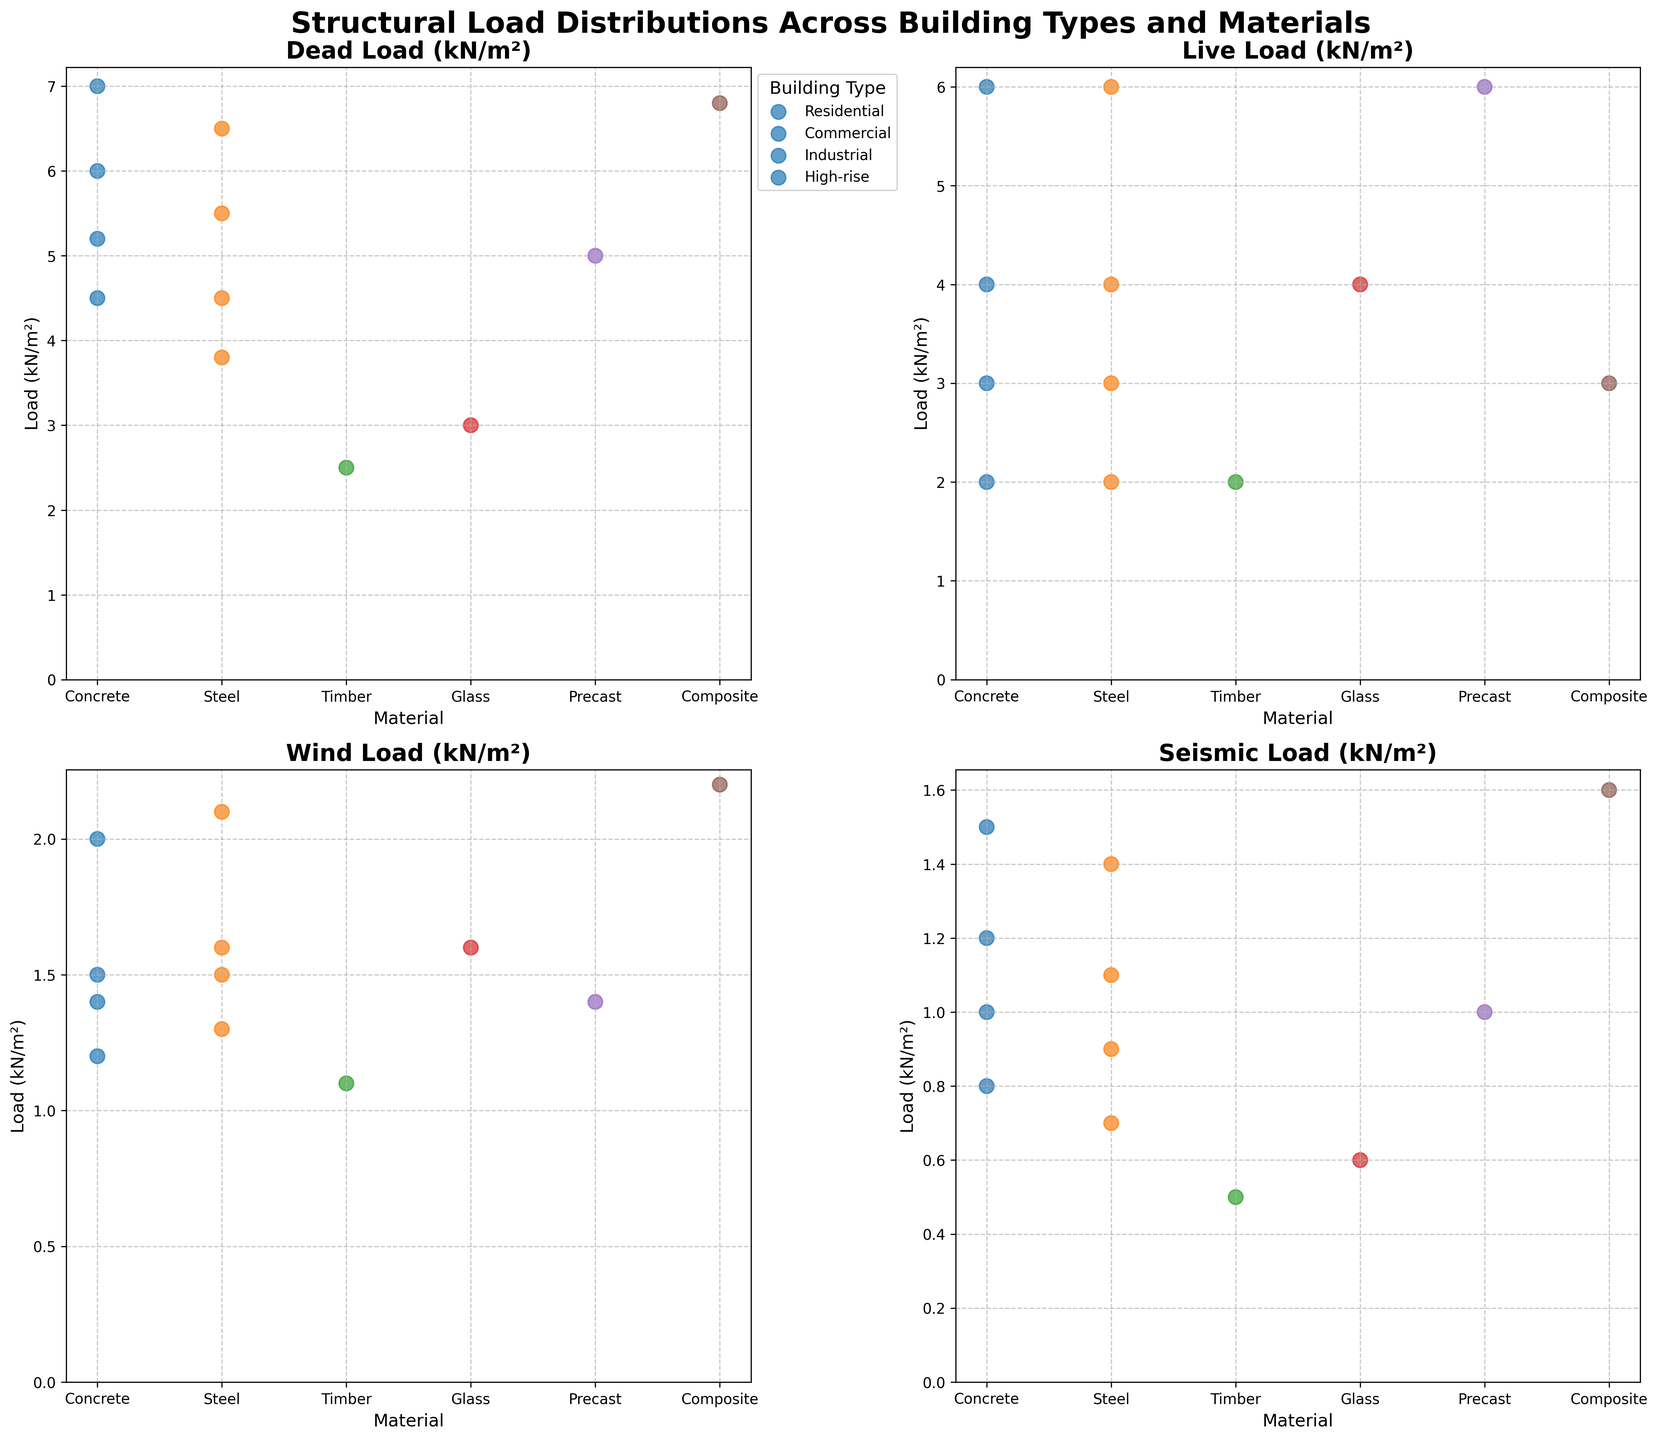What is the title of the figure? The title of the figure is prominently displayed at the top. It reads: "Structural Load Distributions Across Building Types and Materials".
Answer: Structural Load Distributions Across Building Types and Materials Which material is associated with the highest dead load in the High-rise category? The dead load plot shows that in the High-rise category, Concrete has the highest dead load value.
Answer: Concrete How does the seismic load distribution for Residential buildings compare to that for Industrial buildings? By examining the seismic load subplot, it's evident that Residential buildings have lower seismic loads compared to Industrial buildings. Industrial buildings' seismic loads are generally higher across all materials.
Answer: Residential buildings have lower seismic loads than Industrial buildings Which building type shows the most consistent live load across different materials? From the live load subplot, it's clear that the Residential building type maintains a consistent live load of 2.0 kN/m² across Concrete, Steel, and Timber materials.
Answer: Residential What material exhibits the highest wind load in the Commercial building type? The wind load subplot reveals that Glass shows the highest wind load for the Commercial building type.
Answer: Glass Between Steel and Concrete materials, which one generally has higher dead loads across all building types shown in the figure? Observing the dead load subplot, Concrete consistently has higher dead loads compared to Steel across all building types.
Answer: Concrete Which subplot shows the data with the widest range of load values? By comparing all subplots, the Dead Load subplot displays the widest range of load values, spanning from 2.5 kN/m² to 7.0 kN/m².
Answer: Dead Load For the Industrial building type, what is the difference between the highest and lowest seismic loads? In the seismic load subplot, for the Industrial building type, the highest load (Concrete, 1.2) and lowest load (Precast, 1.0) are shown, resulting in a difference of 0.2 kN/m².
Answer: 0.2 kN/m² Among the materials, which one shows the lowest wind load across all building types? Looking at the wind load subplot, Timber shows the lowest wind load across all building types with a value of 1.1 kN/m² in the Residential category.
Answer: Timber 